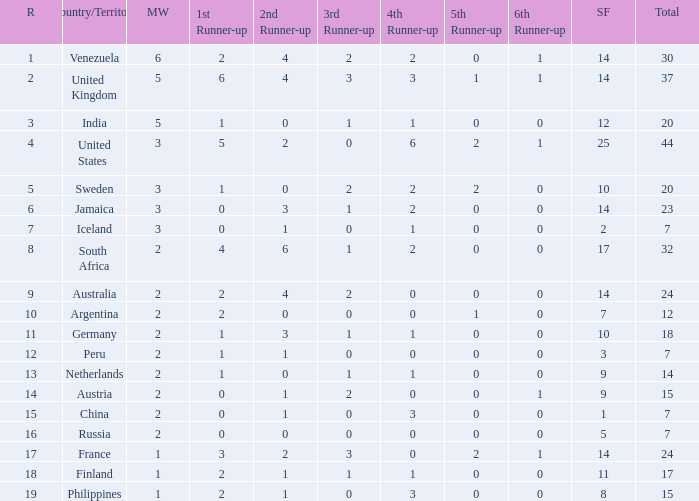What is the United States rank? 1.0. 